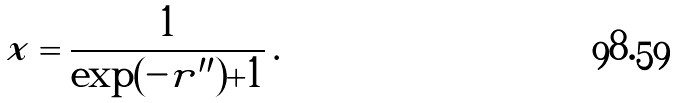Convert formula to latex. <formula><loc_0><loc_0><loc_500><loc_500>x = \frac { 1 } { \exp ( - r ^ { \prime \prime } ) + 1 } \, .</formula> 